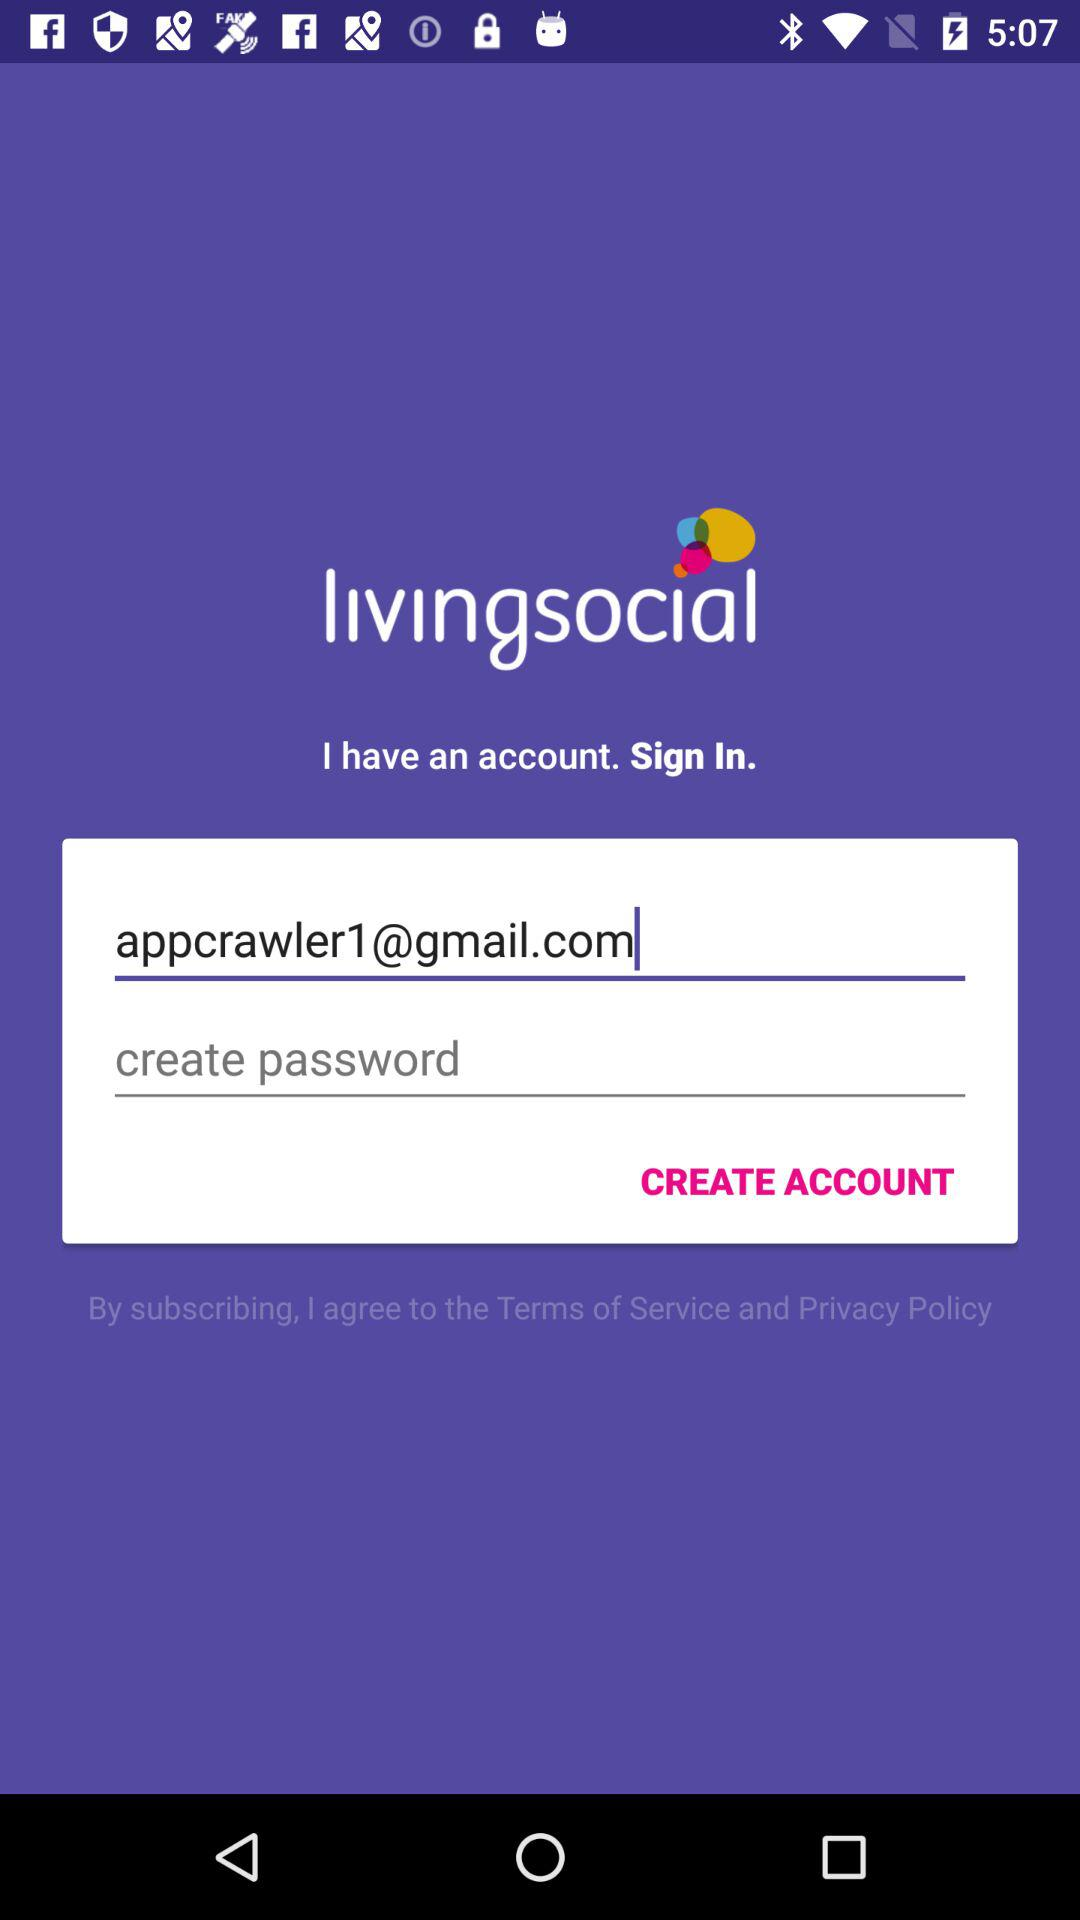How many characters are required to create a password?
When the provided information is insufficient, respond with <no answer>. <no answer> 